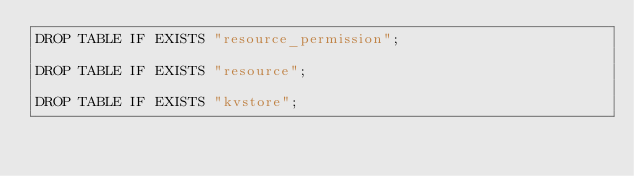<code> <loc_0><loc_0><loc_500><loc_500><_SQL_>DROP TABLE IF EXISTS "resource_permission";

DROP TABLE IF EXISTS "resource";

DROP TABLE IF EXISTS "kvstore";</code> 